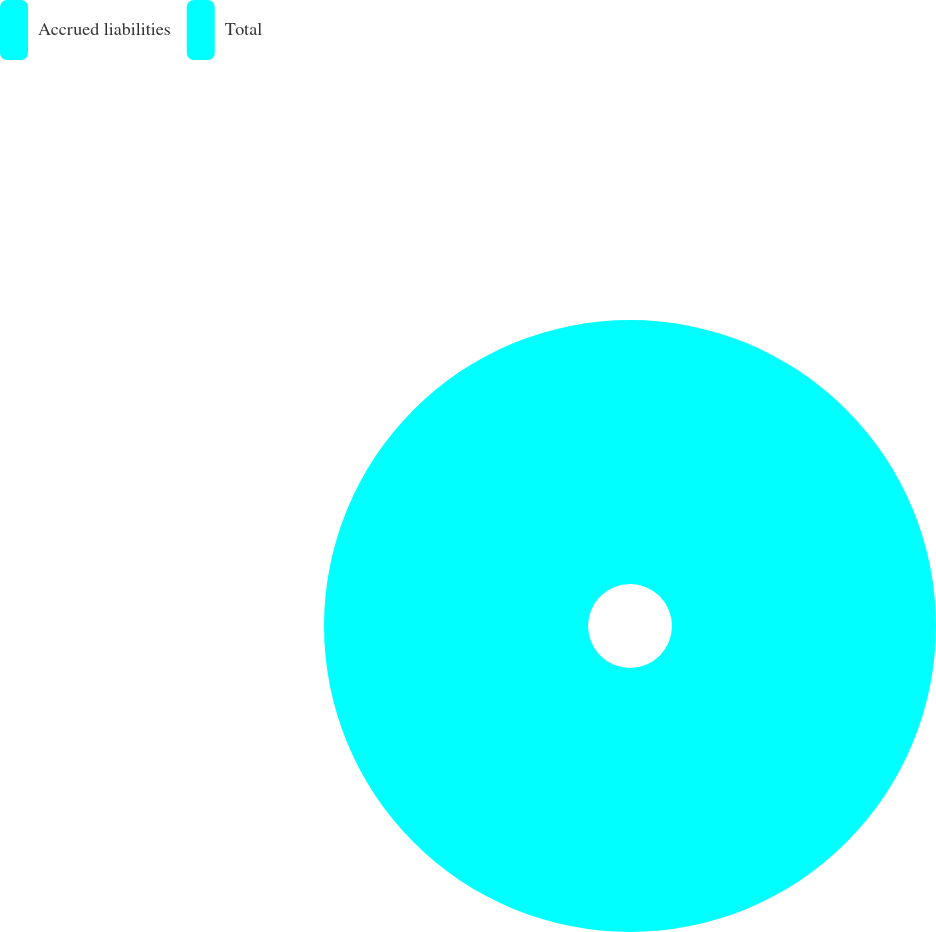Convert chart to OTSL. <chart><loc_0><loc_0><loc_500><loc_500><pie_chart><fcel>Accrued liabilities<fcel>Total<nl><fcel>50.0%<fcel>50.0%<nl></chart> 